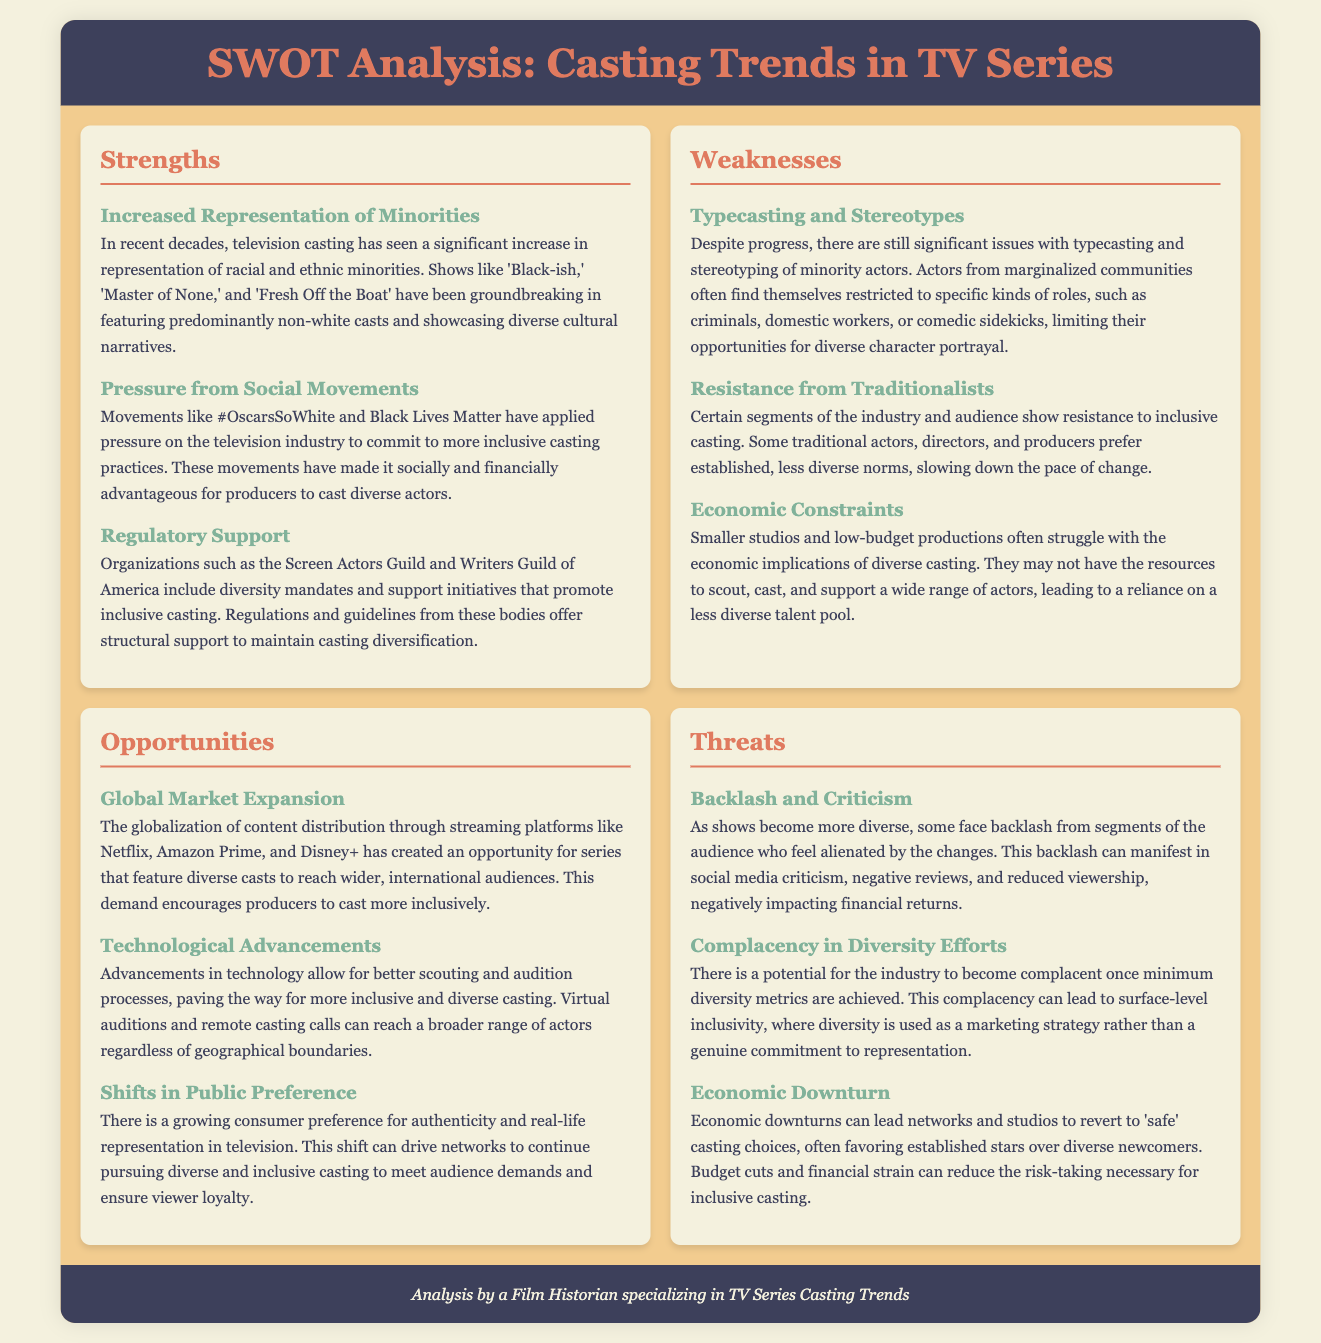what is one of the strengths in TV series casting trends? The document highlights "Increased Representation of Minorities" as a significant strength in recent casting trends.
Answer: Increased Representation of Minorities which social movement has influenced inclusive casting practices? The document mentions that movements like "#OscarsSoWhite" have pressured the industry for more inclusive practices.
Answer: #OscarsSoWhite what is a weakness related to minority actors in TV series? The document points out "Typecasting and Stereotypes" as a weakness affecting minority actors.
Answer: Typecasting and Stereotypes name an opportunity for diverse casting mentioned in the document. The document lists "Global Market Expansion" as an opportunity for diverse casting due to streaming platform growth.
Answer: Global Market Expansion what is one threat to diverse casting mentioned? The document states "Backlash and Criticism" as a threat to diverse casting efforts in TV series.
Answer: Backlash and Criticism how do technological advancements affect casting? The document notes that technological advancements "allow for better scouting and audition processes."
Answer: better scouting and audition processes what is the potential risk of achieving minimum diversity metrics? The document warns about "Complacency in Diversity Efforts" as a risk once minimum diversity metrics are met.
Answer: Complacency in Diversity Efforts which organization supports initiatives for inclusive casting? The document mentions the "Screen Actors Guild" as an organization that supports inclusive casting initiatives.
Answer: Screen Actors Guild what is one economic constraint faced by studios regarding diversity? The document highlights "Economic Constraints" as a challenge for smaller studios with diverse casting.
Answer: Economic Constraints 